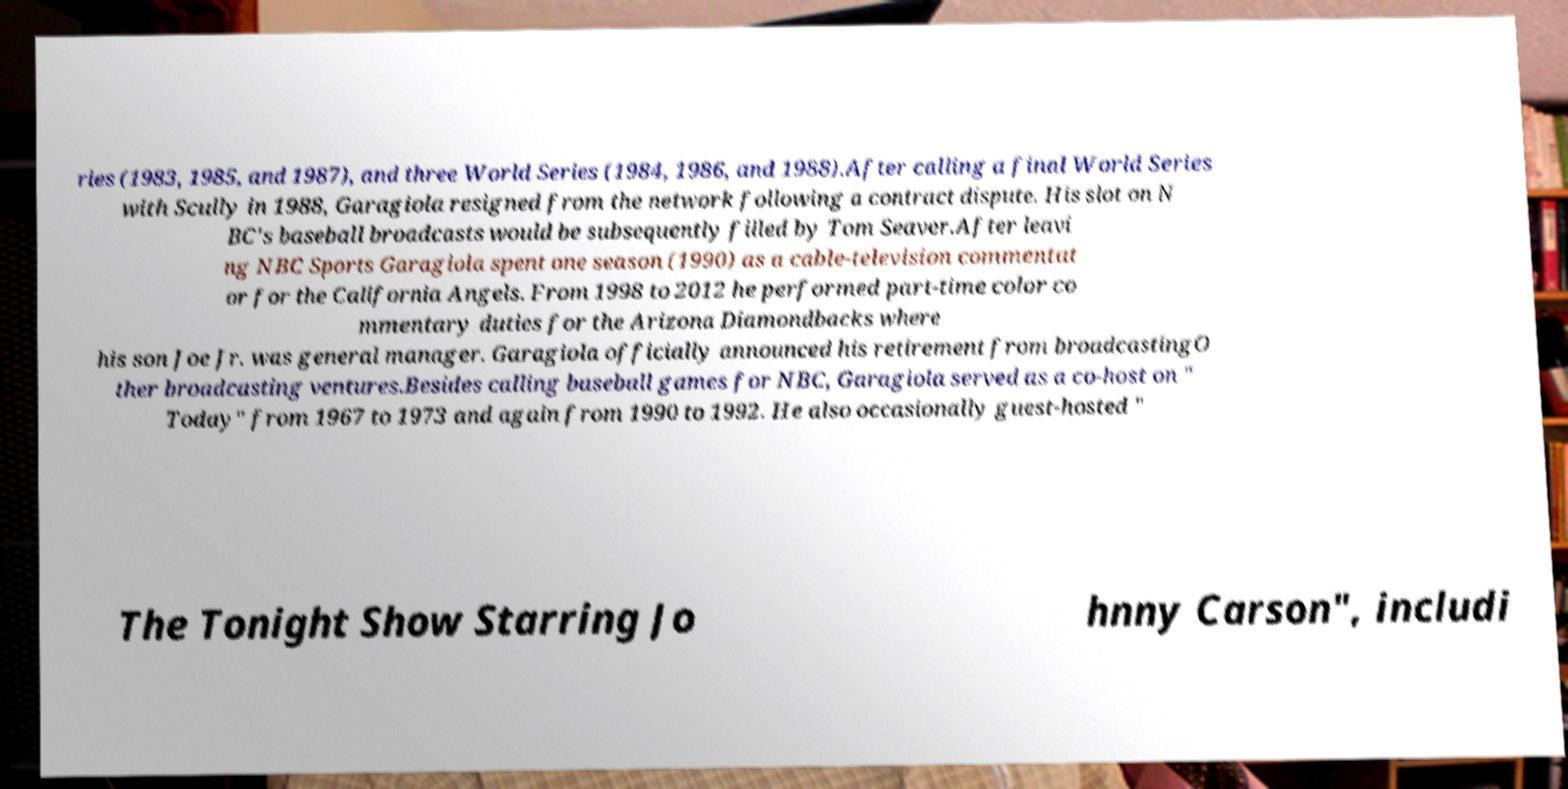Could you assist in decoding the text presented in this image and type it out clearly? ries (1983, 1985, and 1987), and three World Series (1984, 1986, and 1988).After calling a final World Series with Scully in 1988, Garagiola resigned from the network following a contract dispute. His slot on N BC's baseball broadcasts would be subsequently filled by Tom Seaver.After leavi ng NBC Sports Garagiola spent one season (1990) as a cable-television commentat or for the California Angels. From 1998 to 2012 he performed part-time color co mmentary duties for the Arizona Diamondbacks where his son Joe Jr. was general manager. Garagiola officially announced his retirement from broadcastingO ther broadcasting ventures.Besides calling baseball games for NBC, Garagiola served as a co-host on " Today" from 1967 to 1973 and again from 1990 to 1992. He also occasionally guest-hosted " The Tonight Show Starring Jo hnny Carson", includi 